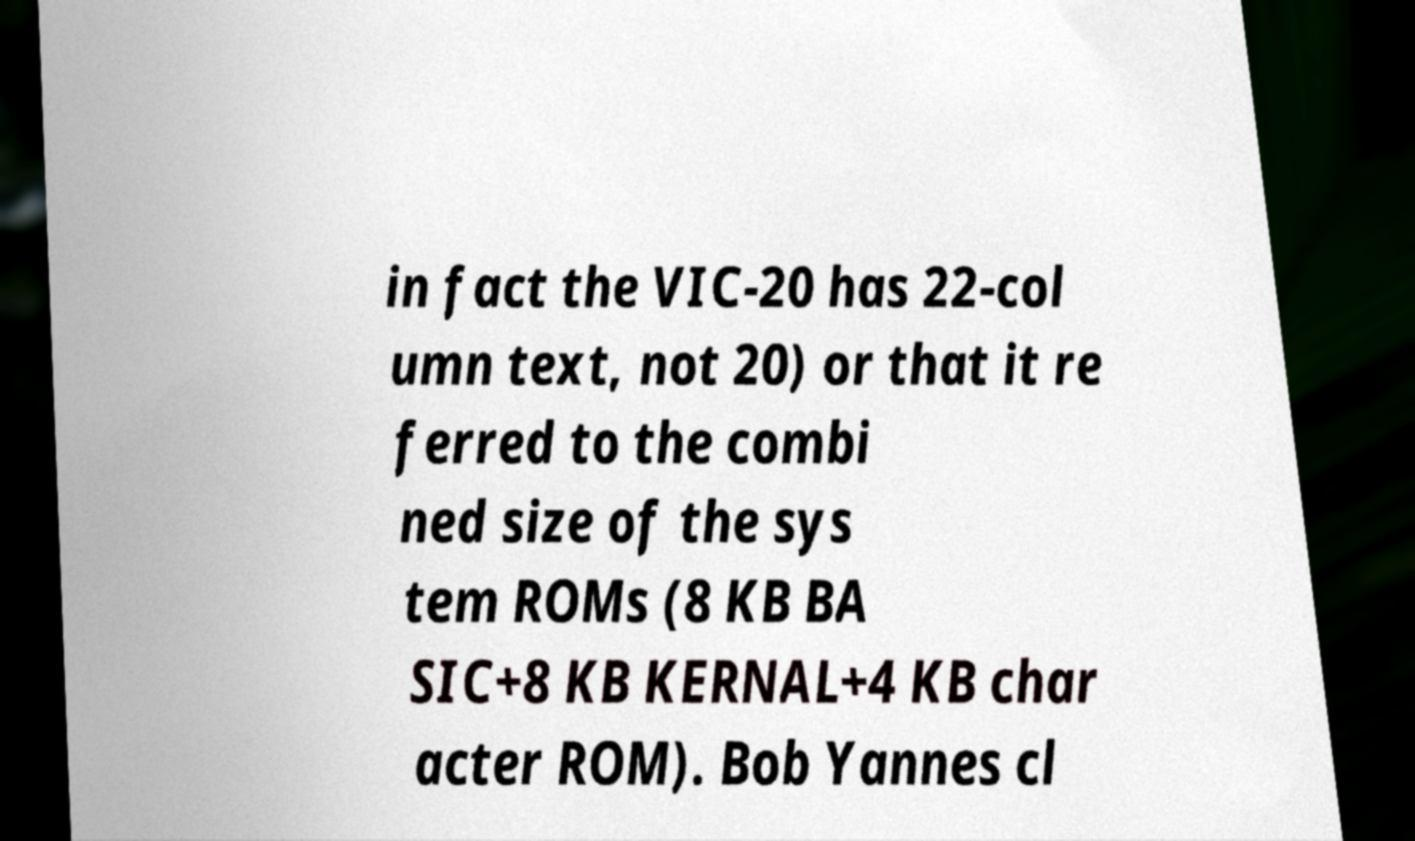Can you accurately transcribe the text from the provided image for me? in fact the VIC-20 has 22-col umn text, not 20) or that it re ferred to the combi ned size of the sys tem ROMs (8 KB BA SIC+8 KB KERNAL+4 KB char acter ROM). Bob Yannes cl 